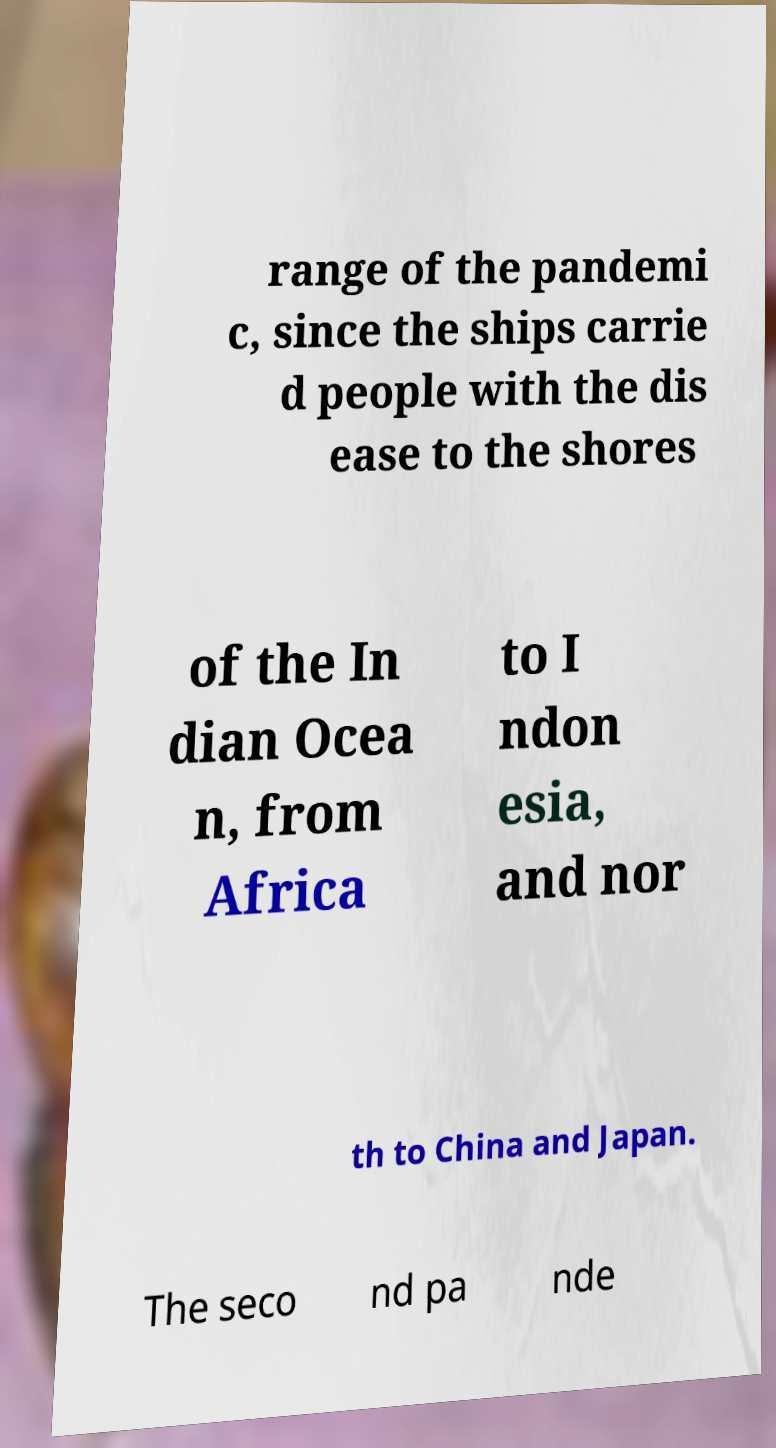I need the written content from this picture converted into text. Can you do that? range of the pandemi c, since the ships carrie d people with the dis ease to the shores of the In dian Ocea n, from Africa to I ndon esia, and nor th to China and Japan. The seco nd pa nde 